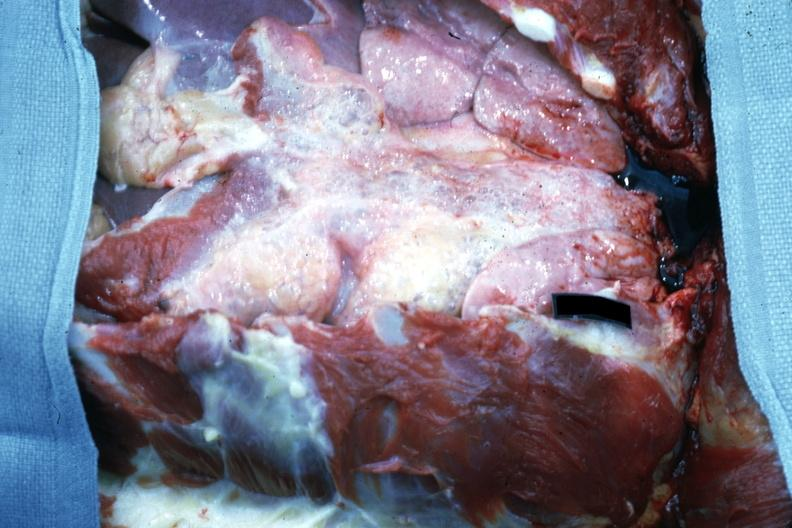s tuberculosis present?
Answer the question using a single word or phrase. No 